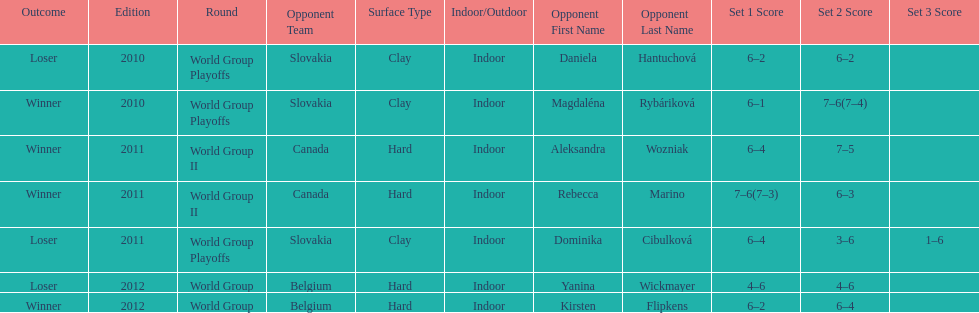What is the other year slovakia played besides 2010? 2011. 